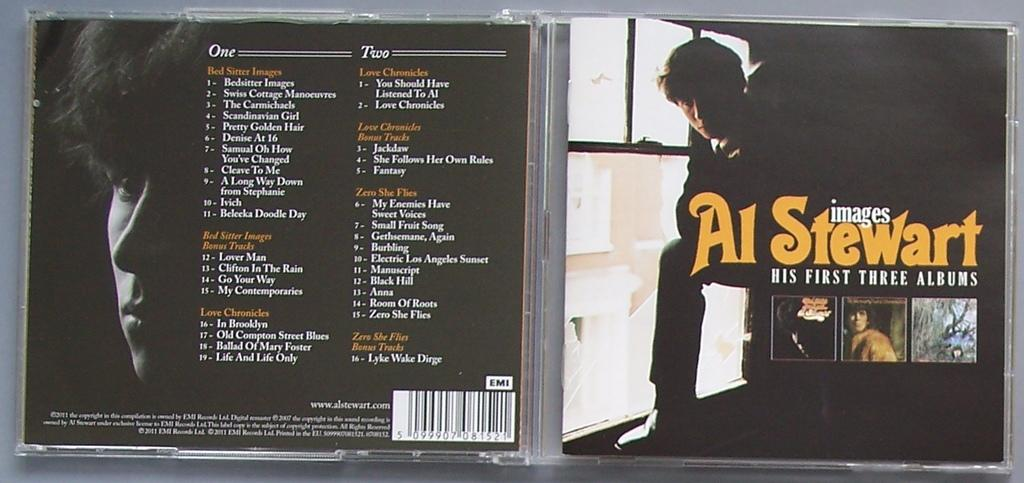How many people are in the image? There are four persons in the image. What else can be seen in the image besides the people? There is text, a logo, trees, a vehicle, a building, a window, and the image appears to be an edited photo. What type of pollution can be seen in the image? There is no pollution visible in the image. Can you see a donkey in the image? No, there is no donkey present in the image. 